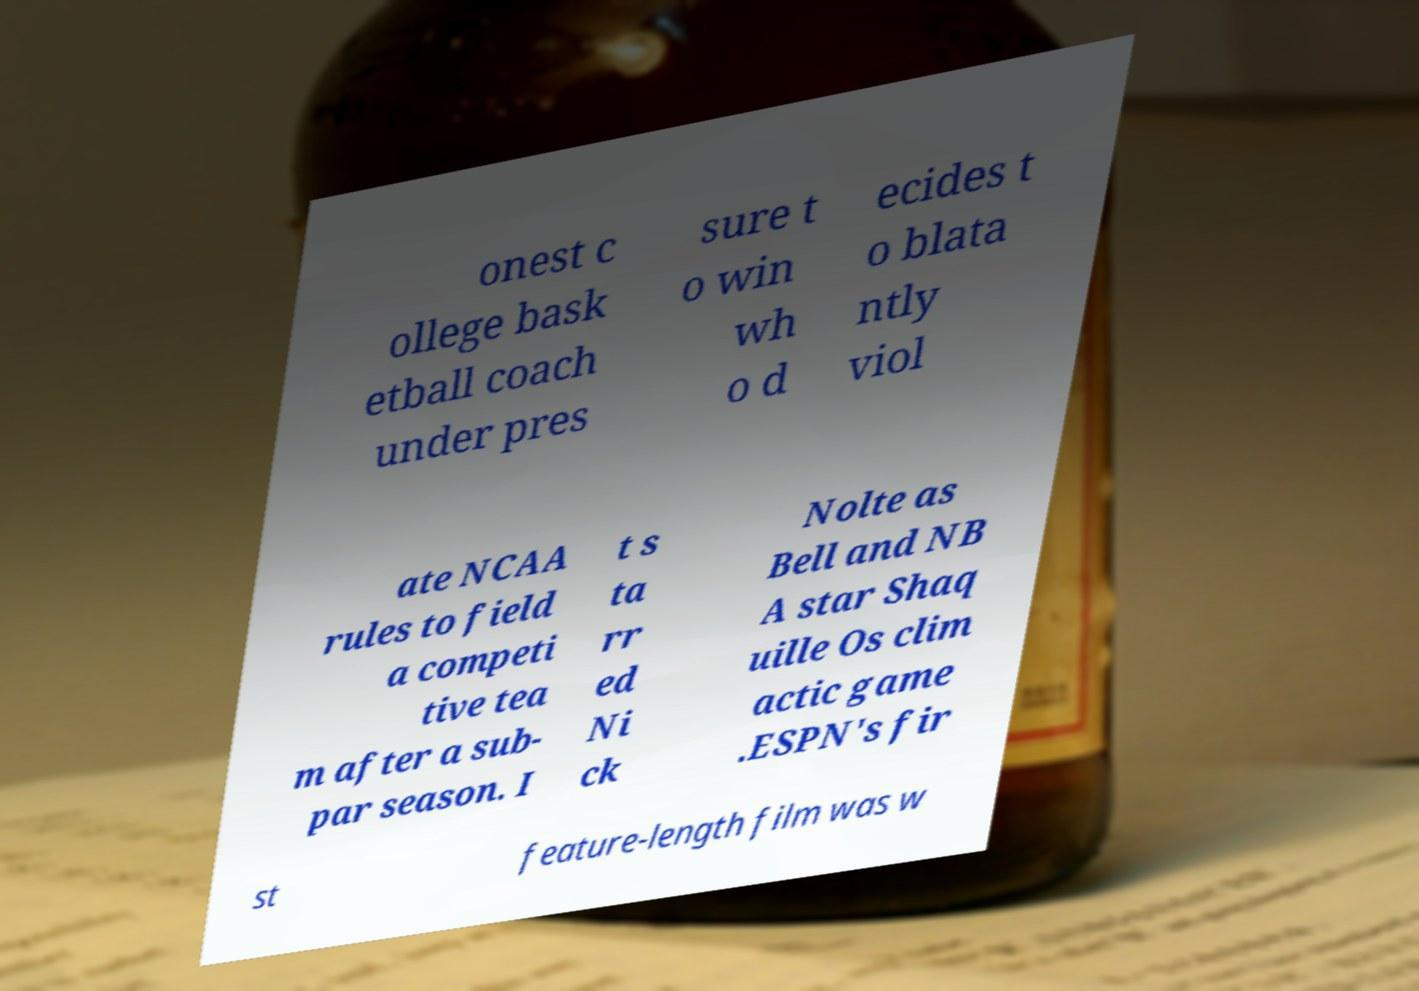Could you assist in decoding the text presented in this image and type it out clearly? onest c ollege bask etball coach under pres sure t o win wh o d ecides t o blata ntly viol ate NCAA rules to field a competi tive tea m after a sub- par season. I t s ta rr ed Ni ck Nolte as Bell and NB A star Shaq uille Os clim actic game .ESPN's fir st feature-length film was w 